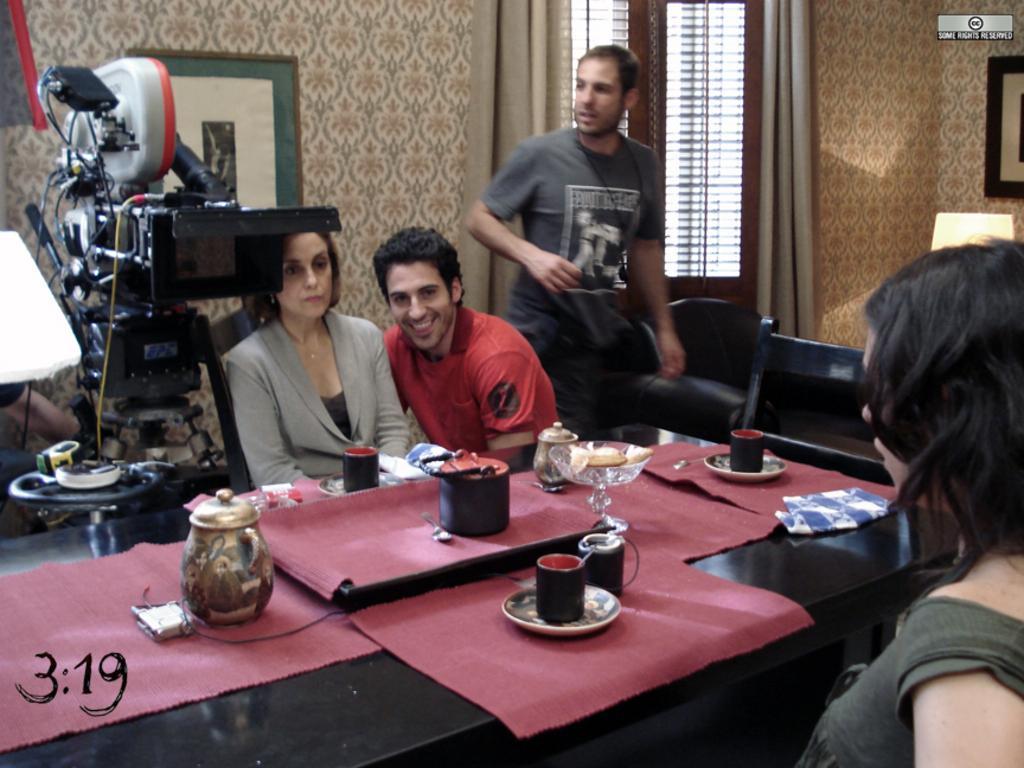Could you give a brief overview of what you see in this image? This picture shows a machine here. Beside the machines there are three members. In front of them there is a woman sitting here. There is a table in the middle. On the table there are some clothes, cups, plates and some bowls here. In the background there is a wall, window and a curtain here. 